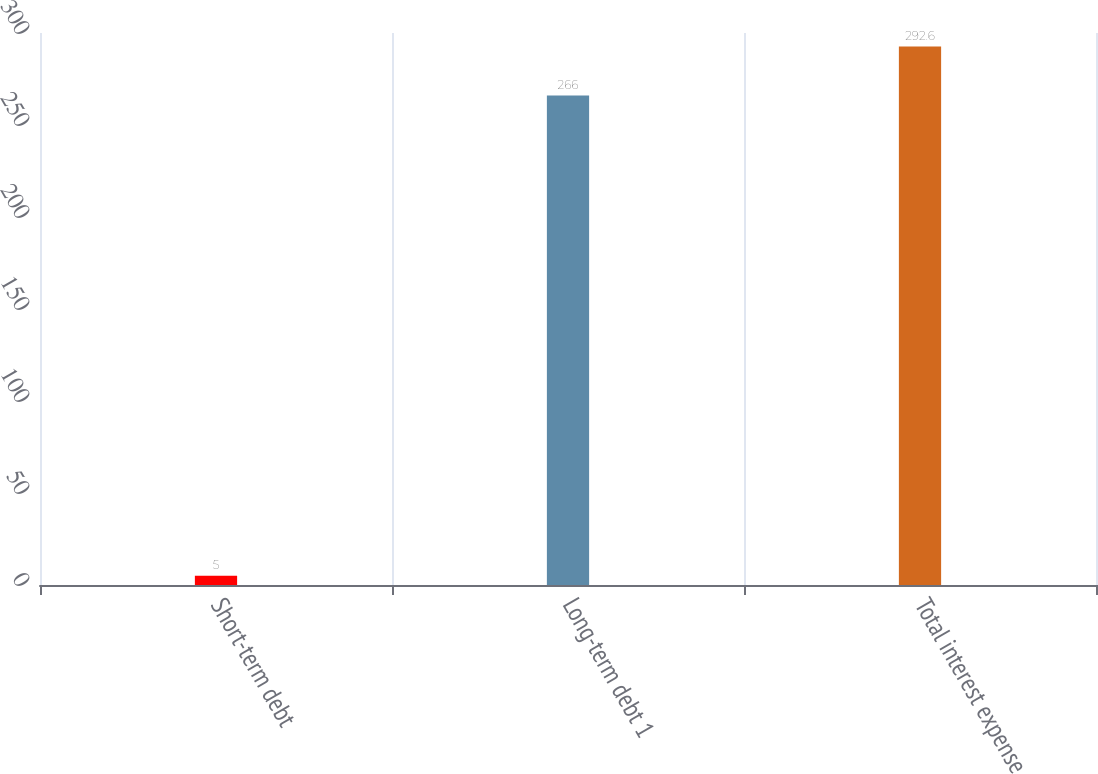<chart> <loc_0><loc_0><loc_500><loc_500><bar_chart><fcel>Short-term debt<fcel>Long-term debt 1<fcel>Total interest expense<nl><fcel>5<fcel>266<fcel>292.6<nl></chart> 